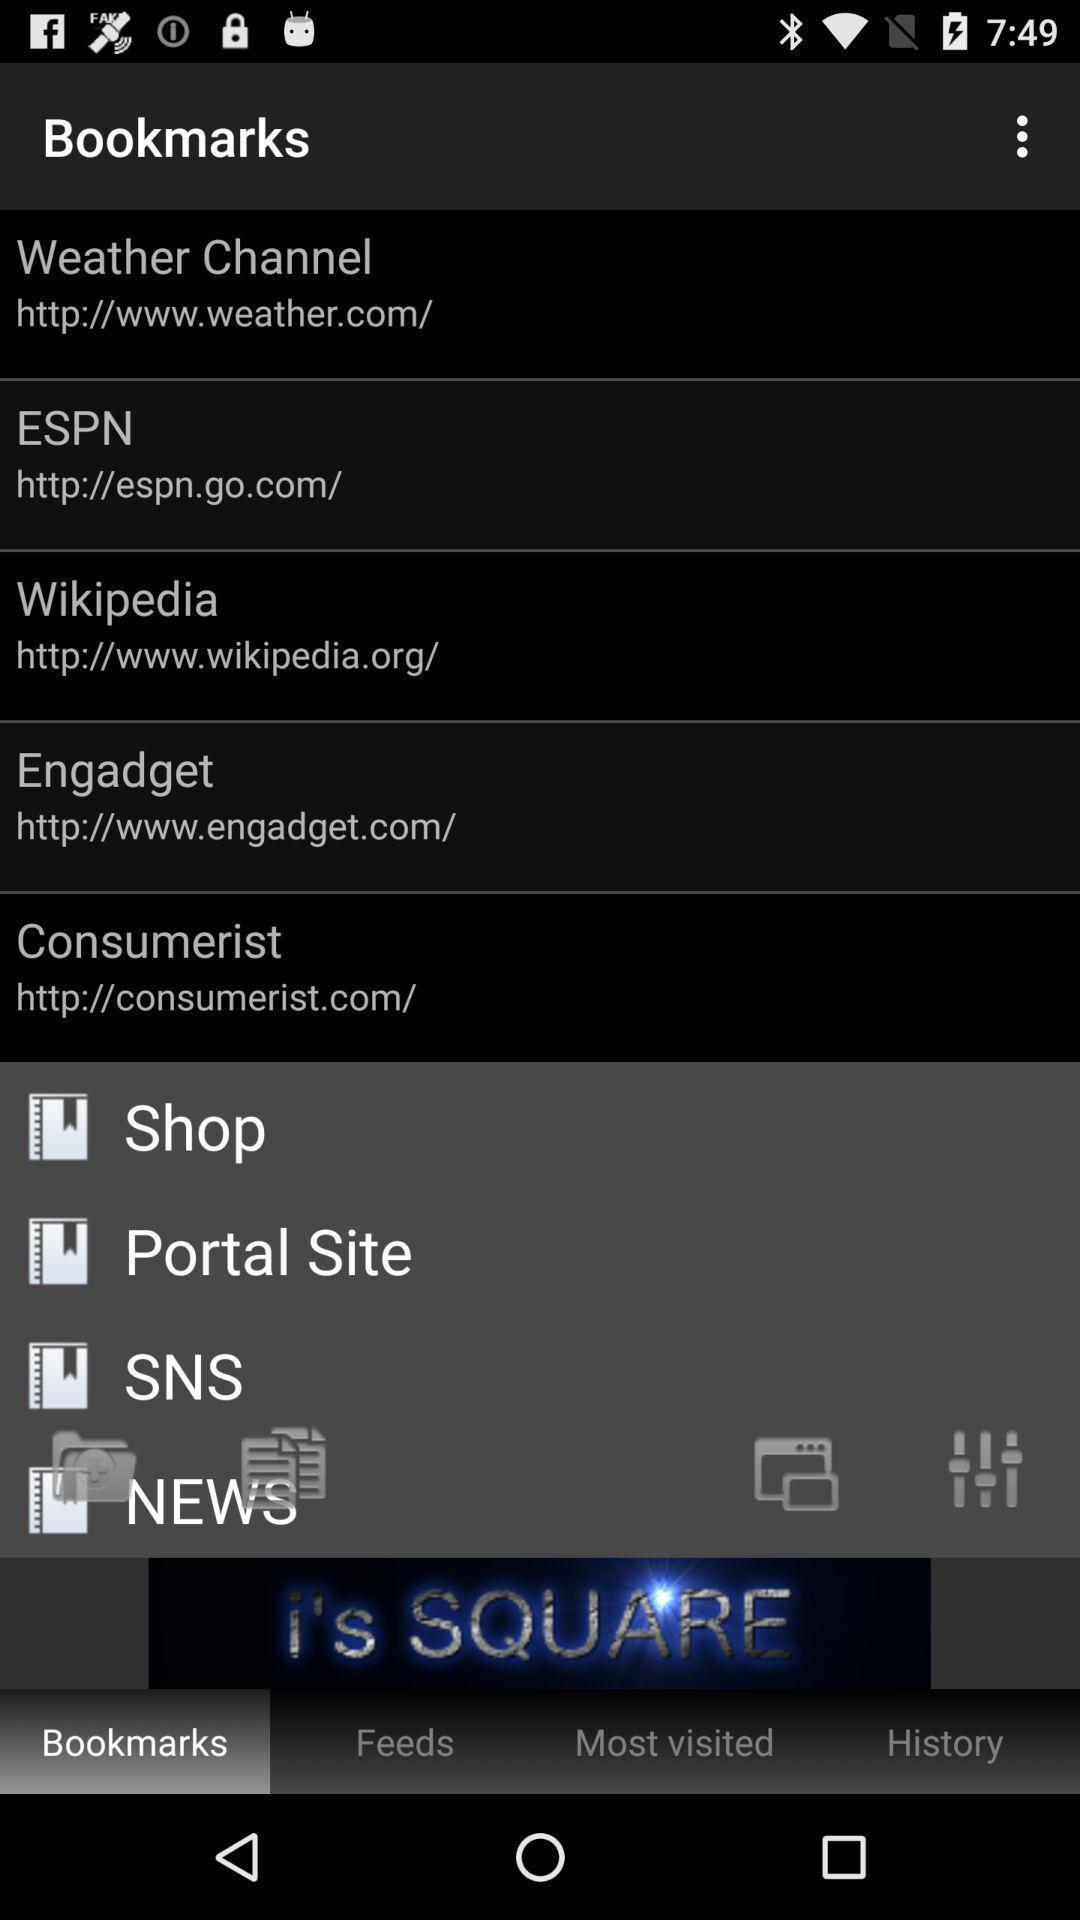What is the URL of the "Weather Channel" bookmark? The URL of the "Weather Channel" bookmark is http://www.weather.com/. 